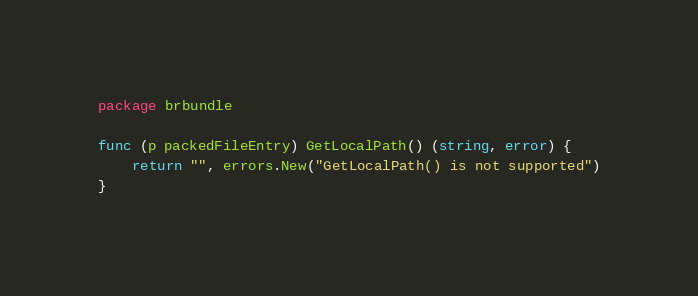Convert code to text. <code><loc_0><loc_0><loc_500><loc_500><_Go_>package brbundle

func (p packedFileEntry) GetLocalPath() (string, error) {
	return "", errors.New("GetLocalPath() is not supported")
}
</code> 